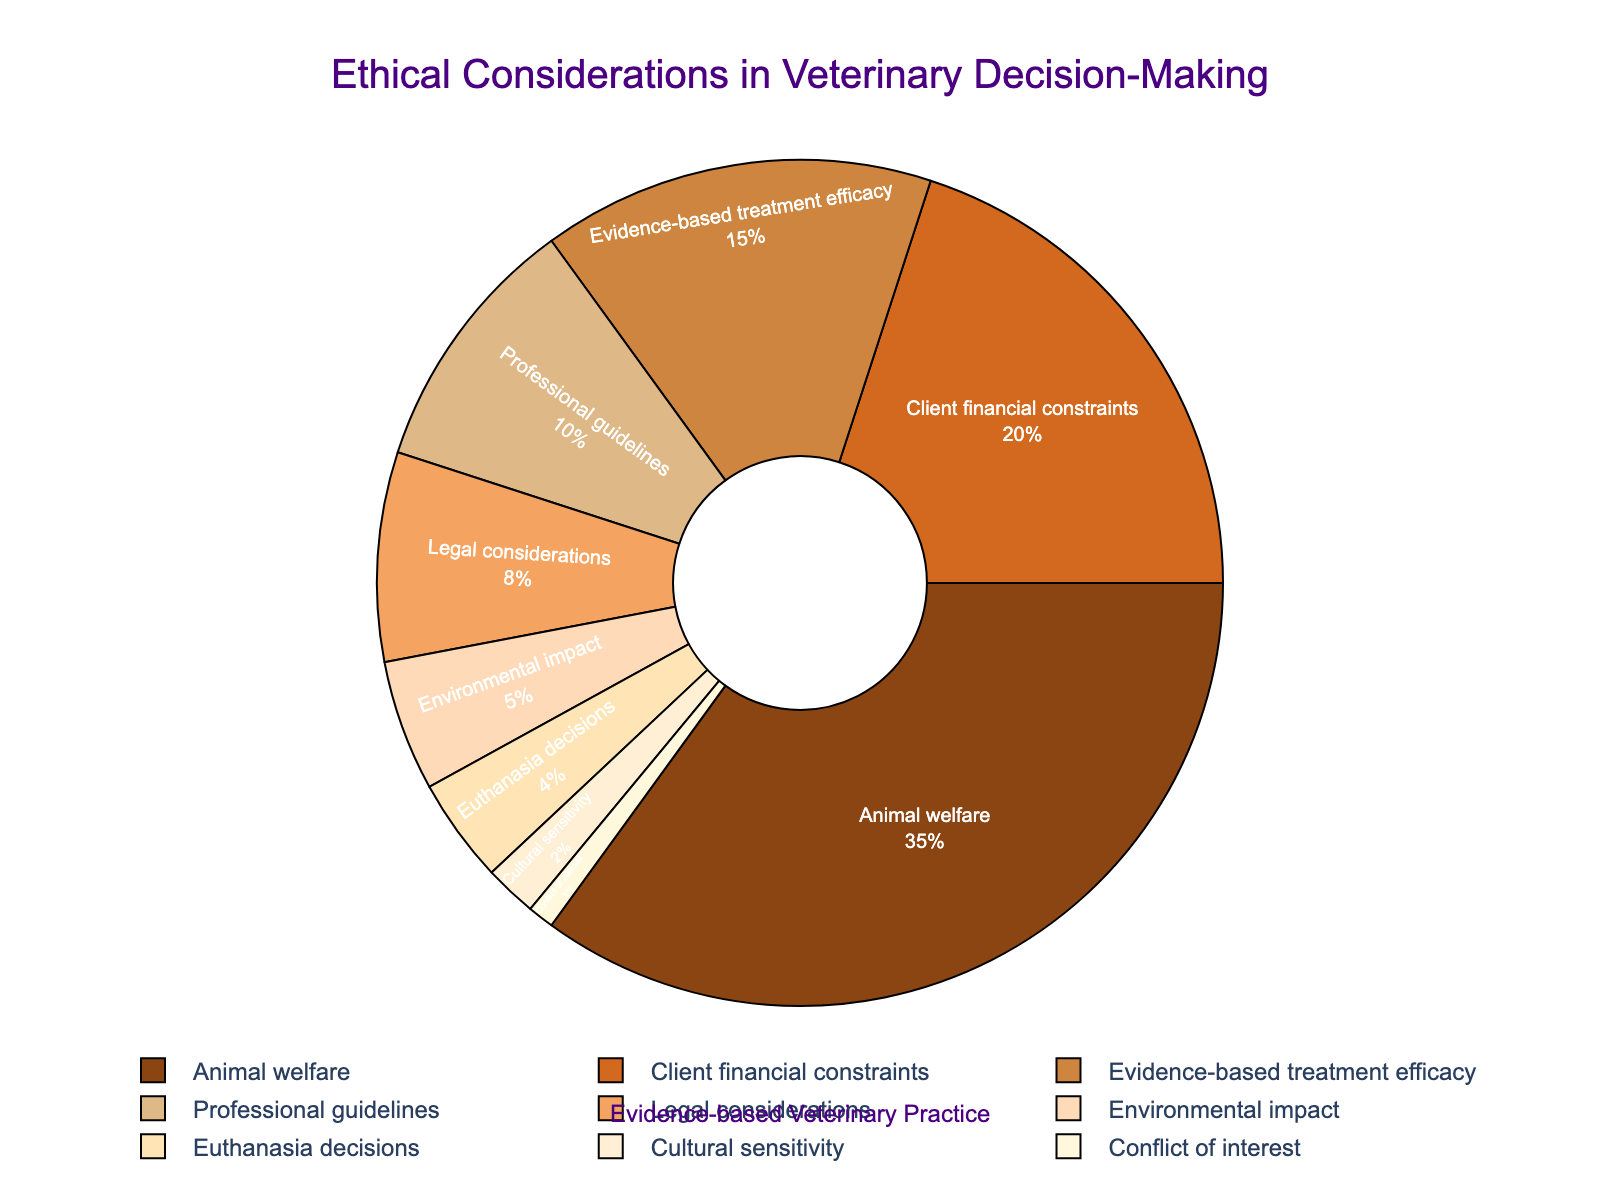Which ethical consideration holds the highest proportion in veterinary decision-making? The pie chart shows the proportion of different ethical considerations. The largest segment of the pie chart represents "Animal welfare."
Answer: Animal welfare Which ethical consideration is the smallest in the pie chart? By examining the pie chart, the smallest segment is labeled "Conflict of interest."
Answer: Conflict of interest How much more is the percentage of 'Animal welfare' compared to 'Legal considerations'? The percentage for "Animal welfare" is 35%, and for "Legal considerations" it is 8%. The difference is calculated by 35% - 8%.
Answer: 27% Between 'Client financial constraints' and 'Evidence-based treatment efficacy,' which one has a higher proportion, and by how much? "Client financial constraints" is represented by 20% and "Evidence-based treatment efficacy" by 15%. The difference is 20% - 15%.
Answer: Client financial constraints; 5% What is the combined percentage of 'Professional guidelines' and 'Legal considerations'? "Professional guidelines" have a percentage of 10% and "Legal considerations" have 8%. The sum is 10% + 8%.
Answer: 18% Which segment is visually represented by a dark brown color, and what is its percentage? The chart mentions that there are different colors assigned to each segment. The segment "Animal welfare" is marked with dark brown.
Answer: Animal welfare; 35% Arrange the top three ethical considerations in descending order of their proportions. The top three ethical considerations by their percentages are "Animal welfare" (35%), "Client financial constraints" (20%), and "Evidence-based treatment efficacy" (15%).
Answer: Animal welfare, Client financial constraints, Evidence-based treatment efficacy What fraction of the chart is taken up by 'Environmental impact' and 'Euthanasia decisions' combined? "Environmental impact" is 5% and "Euthanasia decisions" is 4%. Sum these values to get 5% + 4%. The fraction is then (5% + 4%) / 100%.
Answer: 9/100 or 9% Which ethical consideration is located immediately next to the 'Animal welfare' segment in a clockwise direction on the pie chart? Let us identify the segment immediately next to "Animal welfare" by following the clockwise direction from its position in the pie chart. The next segment in a clockwise direction is "Client financial constraints".
Answer: Client financial constraints 